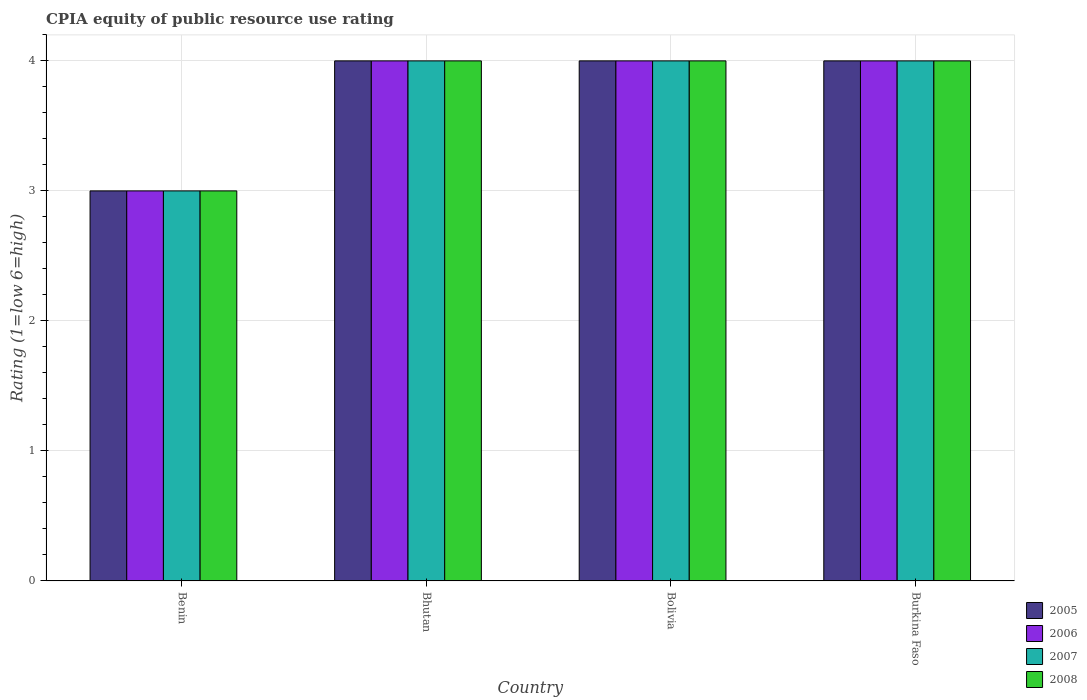How many groups of bars are there?
Ensure brevity in your answer.  4. Are the number of bars per tick equal to the number of legend labels?
Your answer should be compact. Yes. Are the number of bars on each tick of the X-axis equal?
Your answer should be very brief. Yes. How many bars are there on the 4th tick from the left?
Offer a very short reply. 4. What is the label of the 1st group of bars from the left?
Make the answer very short. Benin. Across all countries, what is the minimum CPIA rating in 2007?
Offer a terse response. 3. In which country was the CPIA rating in 2005 maximum?
Keep it short and to the point. Bhutan. In which country was the CPIA rating in 2006 minimum?
Provide a short and direct response. Benin. What is the average CPIA rating in 2005 per country?
Ensure brevity in your answer.  3.75. What is the difference between the CPIA rating of/in 2007 and CPIA rating of/in 2008 in Bolivia?
Offer a very short reply. 0. Is the difference between the CPIA rating in 2007 in Bhutan and Burkina Faso greater than the difference between the CPIA rating in 2008 in Bhutan and Burkina Faso?
Your answer should be very brief. No. What is the difference between the highest and the lowest CPIA rating in 2006?
Your answer should be very brief. 1. Is the sum of the CPIA rating in 2005 in Bhutan and Bolivia greater than the maximum CPIA rating in 2008 across all countries?
Give a very brief answer. Yes. Is it the case that in every country, the sum of the CPIA rating in 2007 and CPIA rating in 2008 is greater than the sum of CPIA rating in 2005 and CPIA rating in 2006?
Your answer should be compact. No. What does the 1st bar from the left in Bolivia represents?
Provide a succinct answer. 2005. What is the difference between two consecutive major ticks on the Y-axis?
Offer a terse response. 1. Are the values on the major ticks of Y-axis written in scientific E-notation?
Make the answer very short. No. Does the graph contain grids?
Offer a very short reply. Yes. How many legend labels are there?
Offer a terse response. 4. What is the title of the graph?
Keep it short and to the point. CPIA equity of public resource use rating. What is the Rating (1=low 6=high) of 2006 in Benin?
Ensure brevity in your answer.  3. What is the Rating (1=low 6=high) of 2008 in Benin?
Your response must be concise. 3. What is the Rating (1=low 6=high) of 2005 in Bhutan?
Provide a succinct answer. 4. What is the Rating (1=low 6=high) in 2007 in Bhutan?
Offer a very short reply. 4. What is the Rating (1=low 6=high) in 2005 in Bolivia?
Your answer should be compact. 4. What is the Rating (1=low 6=high) of 2007 in Bolivia?
Offer a terse response. 4. What is the Rating (1=low 6=high) of 2007 in Burkina Faso?
Make the answer very short. 4. Across all countries, what is the maximum Rating (1=low 6=high) in 2008?
Your answer should be compact. 4. What is the total Rating (1=low 6=high) of 2006 in the graph?
Your answer should be compact. 15. What is the total Rating (1=low 6=high) of 2007 in the graph?
Your answer should be very brief. 15. What is the total Rating (1=low 6=high) of 2008 in the graph?
Your answer should be compact. 15. What is the difference between the Rating (1=low 6=high) of 2006 in Benin and that in Bhutan?
Make the answer very short. -1. What is the difference between the Rating (1=low 6=high) in 2007 in Benin and that in Bhutan?
Keep it short and to the point. -1. What is the difference between the Rating (1=low 6=high) in 2008 in Benin and that in Bhutan?
Ensure brevity in your answer.  -1. What is the difference between the Rating (1=low 6=high) of 2006 in Benin and that in Bolivia?
Offer a very short reply. -1. What is the difference between the Rating (1=low 6=high) of 2007 in Benin and that in Bolivia?
Provide a succinct answer. -1. What is the difference between the Rating (1=low 6=high) of 2008 in Benin and that in Bolivia?
Your answer should be very brief. -1. What is the difference between the Rating (1=low 6=high) of 2006 in Benin and that in Burkina Faso?
Your answer should be compact. -1. What is the difference between the Rating (1=low 6=high) in 2007 in Benin and that in Burkina Faso?
Your answer should be very brief. -1. What is the difference between the Rating (1=low 6=high) in 2008 in Benin and that in Burkina Faso?
Offer a terse response. -1. What is the difference between the Rating (1=low 6=high) of 2008 in Bhutan and that in Bolivia?
Your answer should be compact. 0. What is the difference between the Rating (1=low 6=high) in 2006 in Bhutan and that in Burkina Faso?
Ensure brevity in your answer.  0. What is the difference between the Rating (1=low 6=high) of 2005 in Bolivia and that in Burkina Faso?
Provide a short and direct response. 0. What is the difference between the Rating (1=low 6=high) in 2006 in Bolivia and that in Burkina Faso?
Provide a short and direct response. 0. What is the difference between the Rating (1=low 6=high) in 2006 in Benin and the Rating (1=low 6=high) in 2007 in Bhutan?
Offer a very short reply. -1. What is the difference between the Rating (1=low 6=high) of 2007 in Benin and the Rating (1=low 6=high) of 2008 in Bhutan?
Provide a succinct answer. -1. What is the difference between the Rating (1=low 6=high) in 2005 in Benin and the Rating (1=low 6=high) in 2007 in Bolivia?
Your answer should be very brief. -1. What is the difference between the Rating (1=low 6=high) in 2005 in Benin and the Rating (1=low 6=high) in 2008 in Bolivia?
Give a very brief answer. -1. What is the difference between the Rating (1=low 6=high) of 2007 in Benin and the Rating (1=low 6=high) of 2008 in Bolivia?
Ensure brevity in your answer.  -1. What is the difference between the Rating (1=low 6=high) in 2005 in Benin and the Rating (1=low 6=high) in 2006 in Burkina Faso?
Offer a very short reply. -1. What is the difference between the Rating (1=low 6=high) in 2005 in Benin and the Rating (1=low 6=high) in 2008 in Burkina Faso?
Your response must be concise. -1. What is the difference between the Rating (1=low 6=high) in 2006 in Benin and the Rating (1=low 6=high) in 2007 in Burkina Faso?
Make the answer very short. -1. What is the difference between the Rating (1=low 6=high) of 2006 in Benin and the Rating (1=low 6=high) of 2008 in Burkina Faso?
Keep it short and to the point. -1. What is the difference between the Rating (1=low 6=high) of 2005 in Bhutan and the Rating (1=low 6=high) of 2006 in Bolivia?
Your answer should be compact. 0. What is the difference between the Rating (1=low 6=high) of 2005 in Bhutan and the Rating (1=low 6=high) of 2007 in Bolivia?
Provide a short and direct response. 0. What is the difference between the Rating (1=low 6=high) of 2007 in Bhutan and the Rating (1=low 6=high) of 2008 in Bolivia?
Provide a succinct answer. 0. What is the difference between the Rating (1=low 6=high) of 2005 in Bhutan and the Rating (1=low 6=high) of 2006 in Burkina Faso?
Make the answer very short. 0. What is the difference between the Rating (1=low 6=high) of 2005 in Bhutan and the Rating (1=low 6=high) of 2008 in Burkina Faso?
Give a very brief answer. 0. What is the difference between the Rating (1=low 6=high) in 2006 in Bhutan and the Rating (1=low 6=high) in 2007 in Burkina Faso?
Your answer should be very brief. 0. What is the difference between the Rating (1=low 6=high) of 2006 in Bhutan and the Rating (1=low 6=high) of 2008 in Burkina Faso?
Your answer should be compact. 0. What is the difference between the Rating (1=low 6=high) in 2007 in Bhutan and the Rating (1=low 6=high) in 2008 in Burkina Faso?
Provide a short and direct response. 0. What is the difference between the Rating (1=low 6=high) in 2005 in Bolivia and the Rating (1=low 6=high) in 2007 in Burkina Faso?
Provide a short and direct response. 0. What is the difference between the Rating (1=low 6=high) of 2005 in Bolivia and the Rating (1=low 6=high) of 2008 in Burkina Faso?
Give a very brief answer. 0. What is the difference between the Rating (1=low 6=high) of 2006 in Bolivia and the Rating (1=low 6=high) of 2008 in Burkina Faso?
Keep it short and to the point. 0. What is the difference between the Rating (1=low 6=high) in 2007 in Bolivia and the Rating (1=low 6=high) in 2008 in Burkina Faso?
Your answer should be compact. 0. What is the average Rating (1=low 6=high) in 2005 per country?
Provide a short and direct response. 3.75. What is the average Rating (1=low 6=high) in 2006 per country?
Your response must be concise. 3.75. What is the average Rating (1=low 6=high) in 2007 per country?
Keep it short and to the point. 3.75. What is the average Rating (1=low 6=high) of 2008 per country?
Your answer should be compact. 3.75. What is the difference between the Rating (1=low 6=high) of 2005 and Rating (1=low 6=high) of 2008 in Benin?
Ensure brevity in your answer.  0. What is the difference between the Rating (1=low 6=high) of 2006 and Rating (1=low 6=high) of 2007 in Benin?
Your answer should be compact. 0. What is the difference between the Rating (1=low 6=high) of 2006 and Rating (1=low 6=high) of 2008 in Benin?
Give a very brief answer. 0. What is the difference between the Rating (1=low 6=high) of 2005 and Rating (1=low 6=high) of 2007 in Bhutan?
Provide a short and direct response. 0. What is the difference between the Rating (1=low 6=high) of 2006 and Rating (1=low 6=high) of 2008 in Bhutan?
Your answer should be very brief. 0. What is the difference between the Rating (1=low 6=high) of 2007 and Rating (1=low 6=high) of 2008 in Bhutan?
Keep it short and to the point. 0. What is the difference between the Rating (1=low 6=high) in 2005 and Rating (1=low 6=high) in 2006 in Bolivia?
Ensure brevity in your answer.  0. What is the difference between the Rating (1=low 6=high) of 2005 and Rating (1=low 6=high) of 2007 in Bolivia?
Provide a short and direct response. 0. What is the difference between the Rating (1=low 6=high) in 2006 and Rating (1=low 6=high) in 2008 in Bolivia?
Provide a short and direct response. 0. What is the difference between the Rating (1=low 6=high) of 2005 and Rating (1=low 6=high) of 2006 in Burkina Faso?
Make the answer very short. 0. What is the difference between the Rating (1=low 6=high) in 2005 and Rating (1=low 6=high) in 2007 in Burkina Faso?
Provide a succinct answer. 0. What is the difference between the Rating (1=low 6=high) in 2006 and Rating (1=low 6=high) in 2007 in Burkina Faso?
Offer a terse response. 0. What is the difference between the Rating (1=low 6=high) of 2006 and Rating (1=low 6=high) of 2008 in Burkina Faso?
Keep it short and to the point. 0. What is the difference between the Rating (1=low 6=high) in 2007 and Rating (1=low 6=high) in 2008 in Burkina Faso?
Give a very brief answer. 0. What is the ratio of the Rating (1=low 6=high) in 2006 in Benin to that in Bhutan?
Your response must be concise. 0.75. What is the ratio of the Rating (1=low 6=high) in 2008 in Benin to that in Bhutan?
Provide a short and direct response. 0.75. What is the ratio of the Rating (1=low 6=high) in 2006 in Benin to that in Bolivia?
Make the answer very short. 0.75. What is the ratio of the Rating (1=low 6=high) of 2007 in Benin to that in Bolivia?
Give a very brief answer. 0.75. What is the ratio of the Rating (1=low 6=high) of 2008 in Benin to that in Bolivia?
Keep it short and to the point. 0.75. What is the ratio of the Rating (1=low 6=high) of 2005 in Benin to that in Burkina Faso?
Offer a very short reply. 0.75. What is the ratio of the Rating (1=low 6=high) in 2007 in Benin to that in Burkina Faso?
Offer a terse response. 0.75. What is the ratio of the Rating (1=low 6=high) of 2006 in Bhutan to that in Bolivia?
Offer a very short reply. 1. What is the ratio of the Rating (1=low 6=high) of 2008 in Bhutan to that in Bolivia?
Make the answer very short. 1. What is the ratio of the Rating (1=low 6=high) of 2005 in Bhutan to that in Burkina Faso?
Offer a terse response. 1. What is the ratio of the Rating (1=low 6=high) in 2007 in Bhutan to that in Burkina Faso?
Your answer should be very brief. 1. What is the ratio of the Rating (1=low 6=high) in 2008 in Bhutan to that in Burkina Faso?
Your response must be concise. 1. What is the ratio of the Rating (1=low 6=high) in 2005 in Bolivia to that in Burkina Faso?
Make the answer very short. 1. What is the ratio of the Rating (1=low 6=high) of 2006 in Bolivia to that in Burkina Faso?
Your response must be concise. 1. What is the difference between the highest and the second highest Rating (1=low 6=high) in 2006?
Offer a very short reply. 0. What is the difference between the highest and the second highest Rating (1=low 6=high) in 2007?
Ensure brevity in your answer.  0. What is the difference between the highest and the second highest Rating (1=low 6=high) of 2008?
Provide a succinct answer. 0. What is the difference between the highest and the lowest Rating (1=low 6=high) of 2005?
Offer a terse response. 1. 